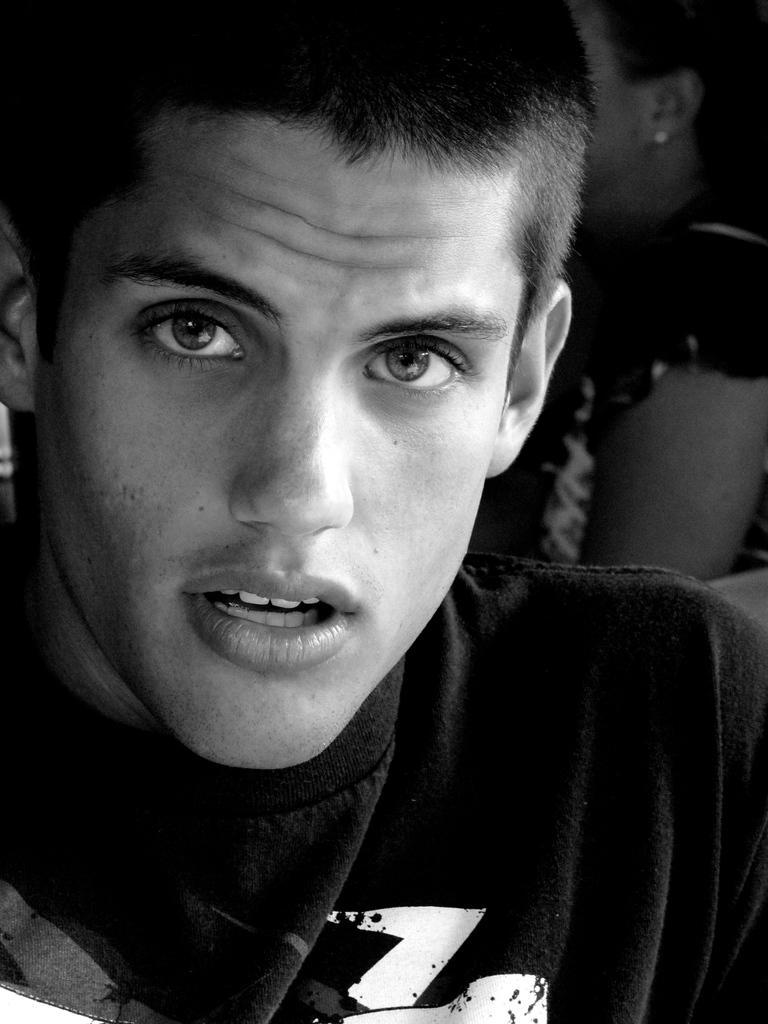How many people are present in the image? There are two persons in the image. What type of birds can be seen making a selection from the lock in the image? There are no birds or locks present in the image; it features two persons. 